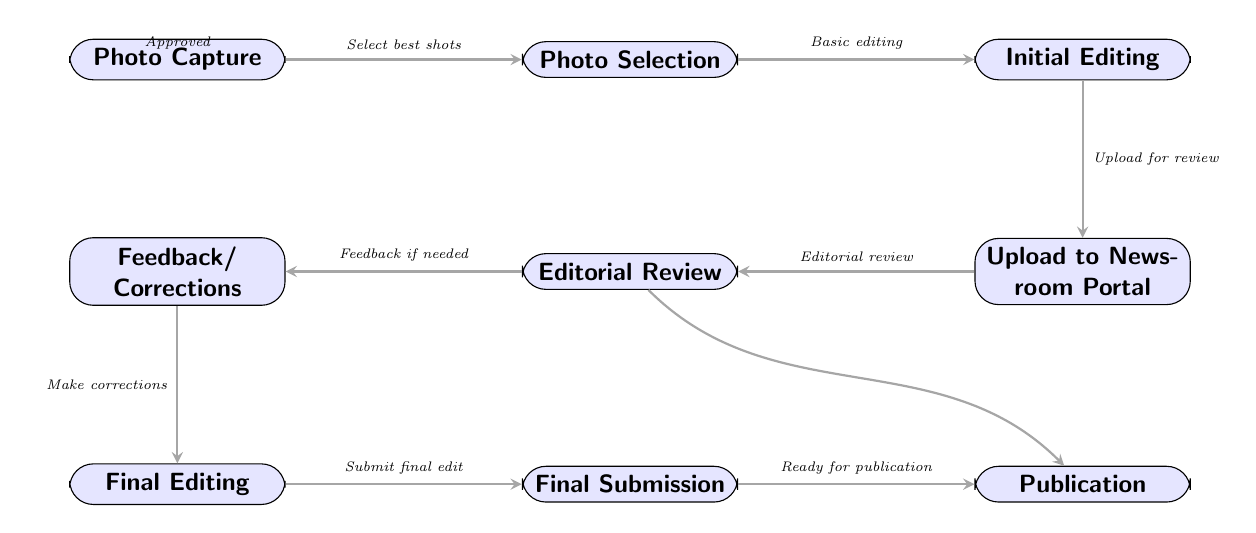What is the first step in the workflow? The first step in the workflow according to the diagram is "Photo Capture." This is identified as the starting node before any editing or submission occurs.
Answer: Photo Capture How many nodes are present in the diagram? By counting, we find nine distinct nodes in the workflow diagram that represent different stages of the photo submission process.
Answer: Nine What action follows "Photo Selection"? The action that follows "Photo Selection" is "Initial Editing." This is indicated by the directed edge connecting the two nodes in the workflow.
Answer: Initial Editing What occurs after "Editorial Review" if feedback is needed? If feedback is required after "Editorial Review," then the next action is "Feedback/ Corrections." This is a conditional step that indicates a loop back to corrections rather than proceeding to publication.
Answer: Feedback/ Corrections Which node is connected to "Final Submission"? The node connected to "Final Submission" is "Publication." The directed edge shows that once the final edit is submitted, it is ready for publication.
Answer: Publication What does the arrow from "Editorial Review" to "Publication" signify? The arrow from "Editorial Review" to "Publication" signifies that if the editorial review is approved, the photos can move directly to publication, skipping feedback. Thus, this edge represents a successful approval process.
Answer: Approved What step comes immediately after "Final Editing"? Immediately after "Final Editing," the next step is "Final Submission," which represents the submission of the edited photos for publication.
Answer: Final Submission How many decision nodes are present in the diagram? There are two decision nodes in the flow: one after "Editorial Review" (whether feedback is needed) and another path taking photos directly to "Publication" upon approval. This structure creates decision points in the workflow.
Answer: Two 